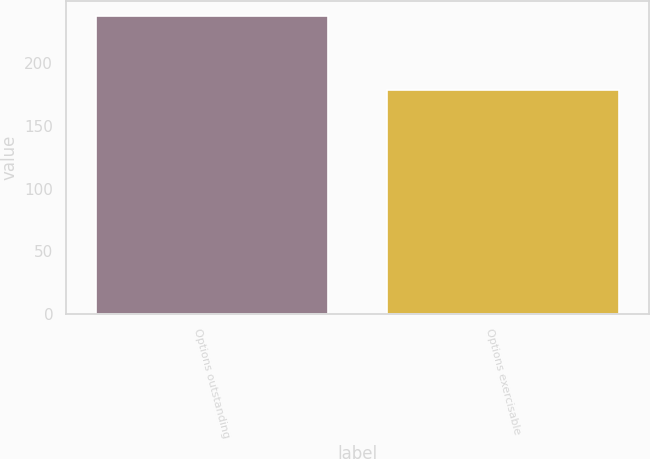Convert chart to OTSL. <chart><loc_0><loc_0><loc_500><loc_500><bar_chart><fcel>Options outstanding<fcel>Options exercisable<nl><fcel>238<fcel>179<nl></chart> 